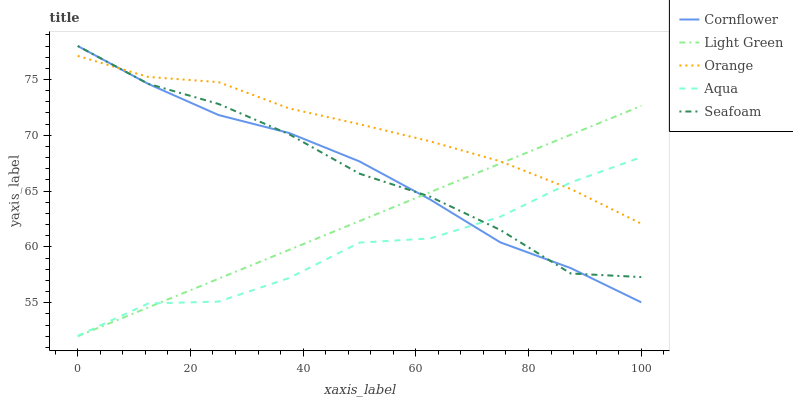Does Aqua have the minimum area under the curve?
Answer yes or no. Yes. Does Orange have the maximum area under the curve?
Answer yes or no. Yes. Does Cornflower have the minimum area under the curve?
Answer yes or no. No. Does Cornflower have the maximum area under the curve?
Answer yes or no. No. Is Light Green the smoothest?
Answer yes or no. Yes. Is Aqua the roughest?
Answer yes or no. Yes. Is Cornflower the smoothest?
Answer yes or no. No. Is Cornflower the roughest?
Answer yes or no. No. Does Cornflower have the lowest value?
Answer yes or no. No. Does Seafoam have the highest value?
Answer yes or no. Yes. Does Aqua have the highest value?
Answer yes or no. No. Does Cornflower intersect Light Green?
Answer yes or no. Yes. Is Cornflower less than Light Green?
Answer yes or no. No. Is Cornflower greater than Light Green?
Answer yes or no. No. 